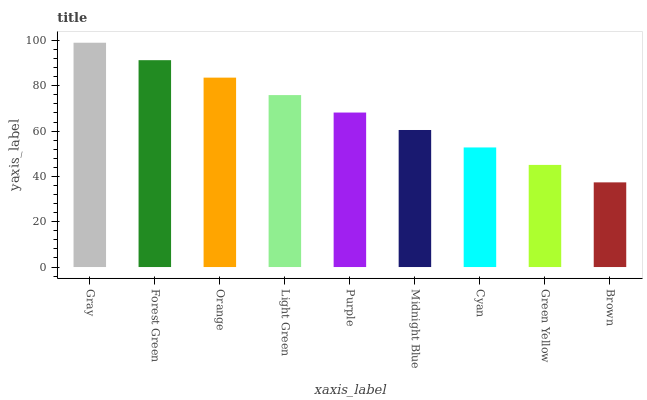Is Brown the minimum?
Answer yes or no. Yes. Is Gray the maximum?
Answer yes or no. Yes. Is Forest Green the minimum?
Answer yes or no. No. Is Forest Green the maximum?
Answer yes or no. No. Is Gray greater than Forest Green?
Answer yes or no. Yes. Is Forest Green less than Gray?
Answer yes or no. Yes. Is Forest Green greater than Gray?
Answer yes or no. No. Is Gray less than Forest Green?
Answer yes or no. No. Is Purple the high median?
Answer yes or no. Yes. Is Purple the low median?
Answer yes or no. Yes. Is Gray the high median?
Answer yes or no. No. Is Green Yellow the low median?
Answer yes or no. No. 